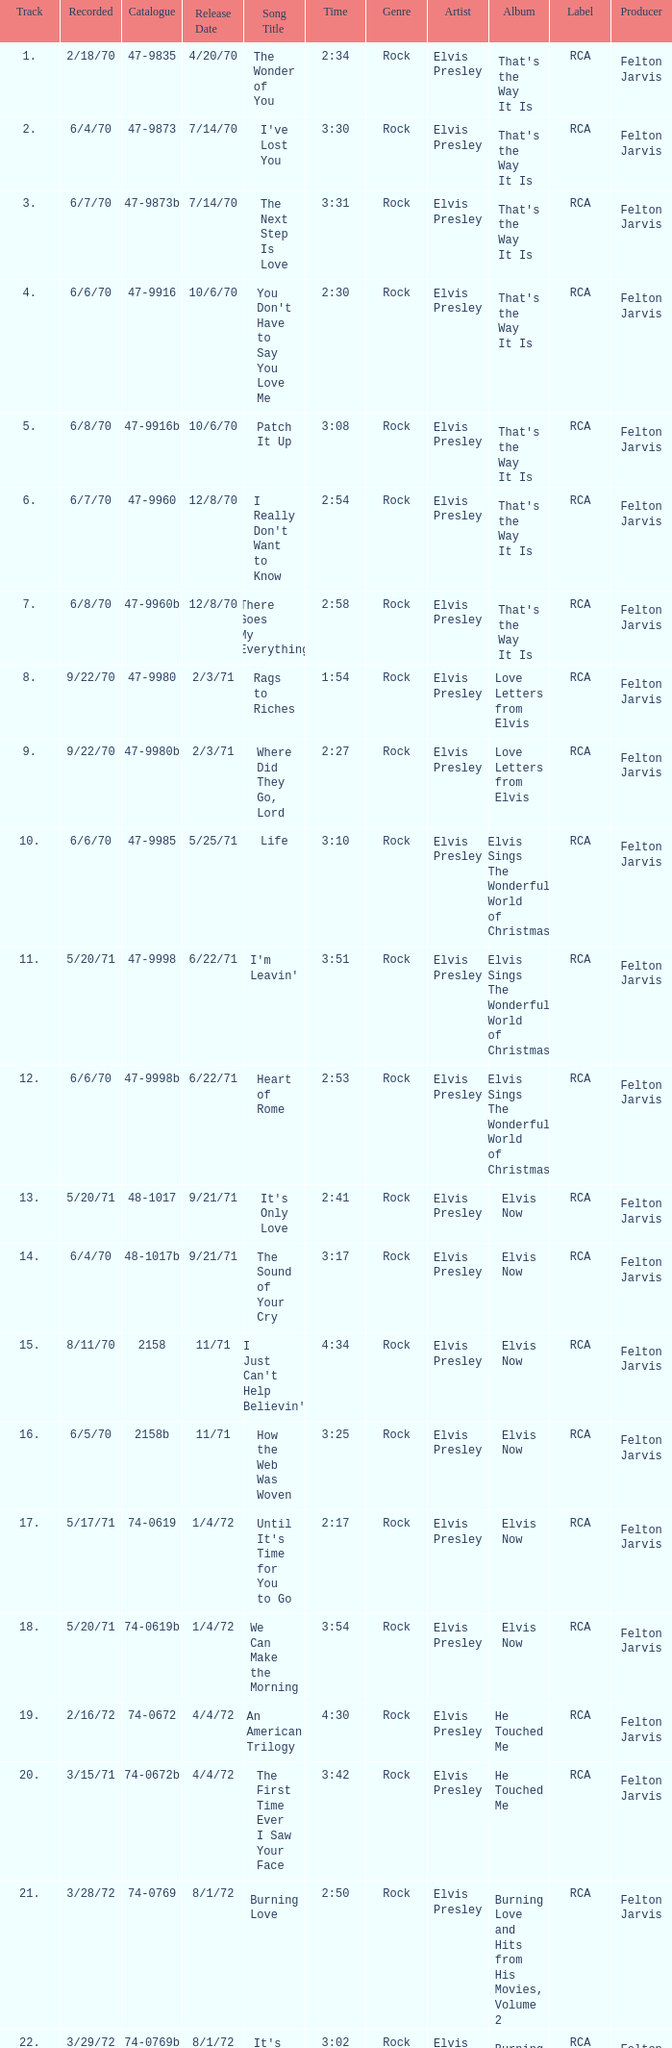What is the catalogue number for the song that is 3:17 and was released 9/21/71? 48-1017b. 